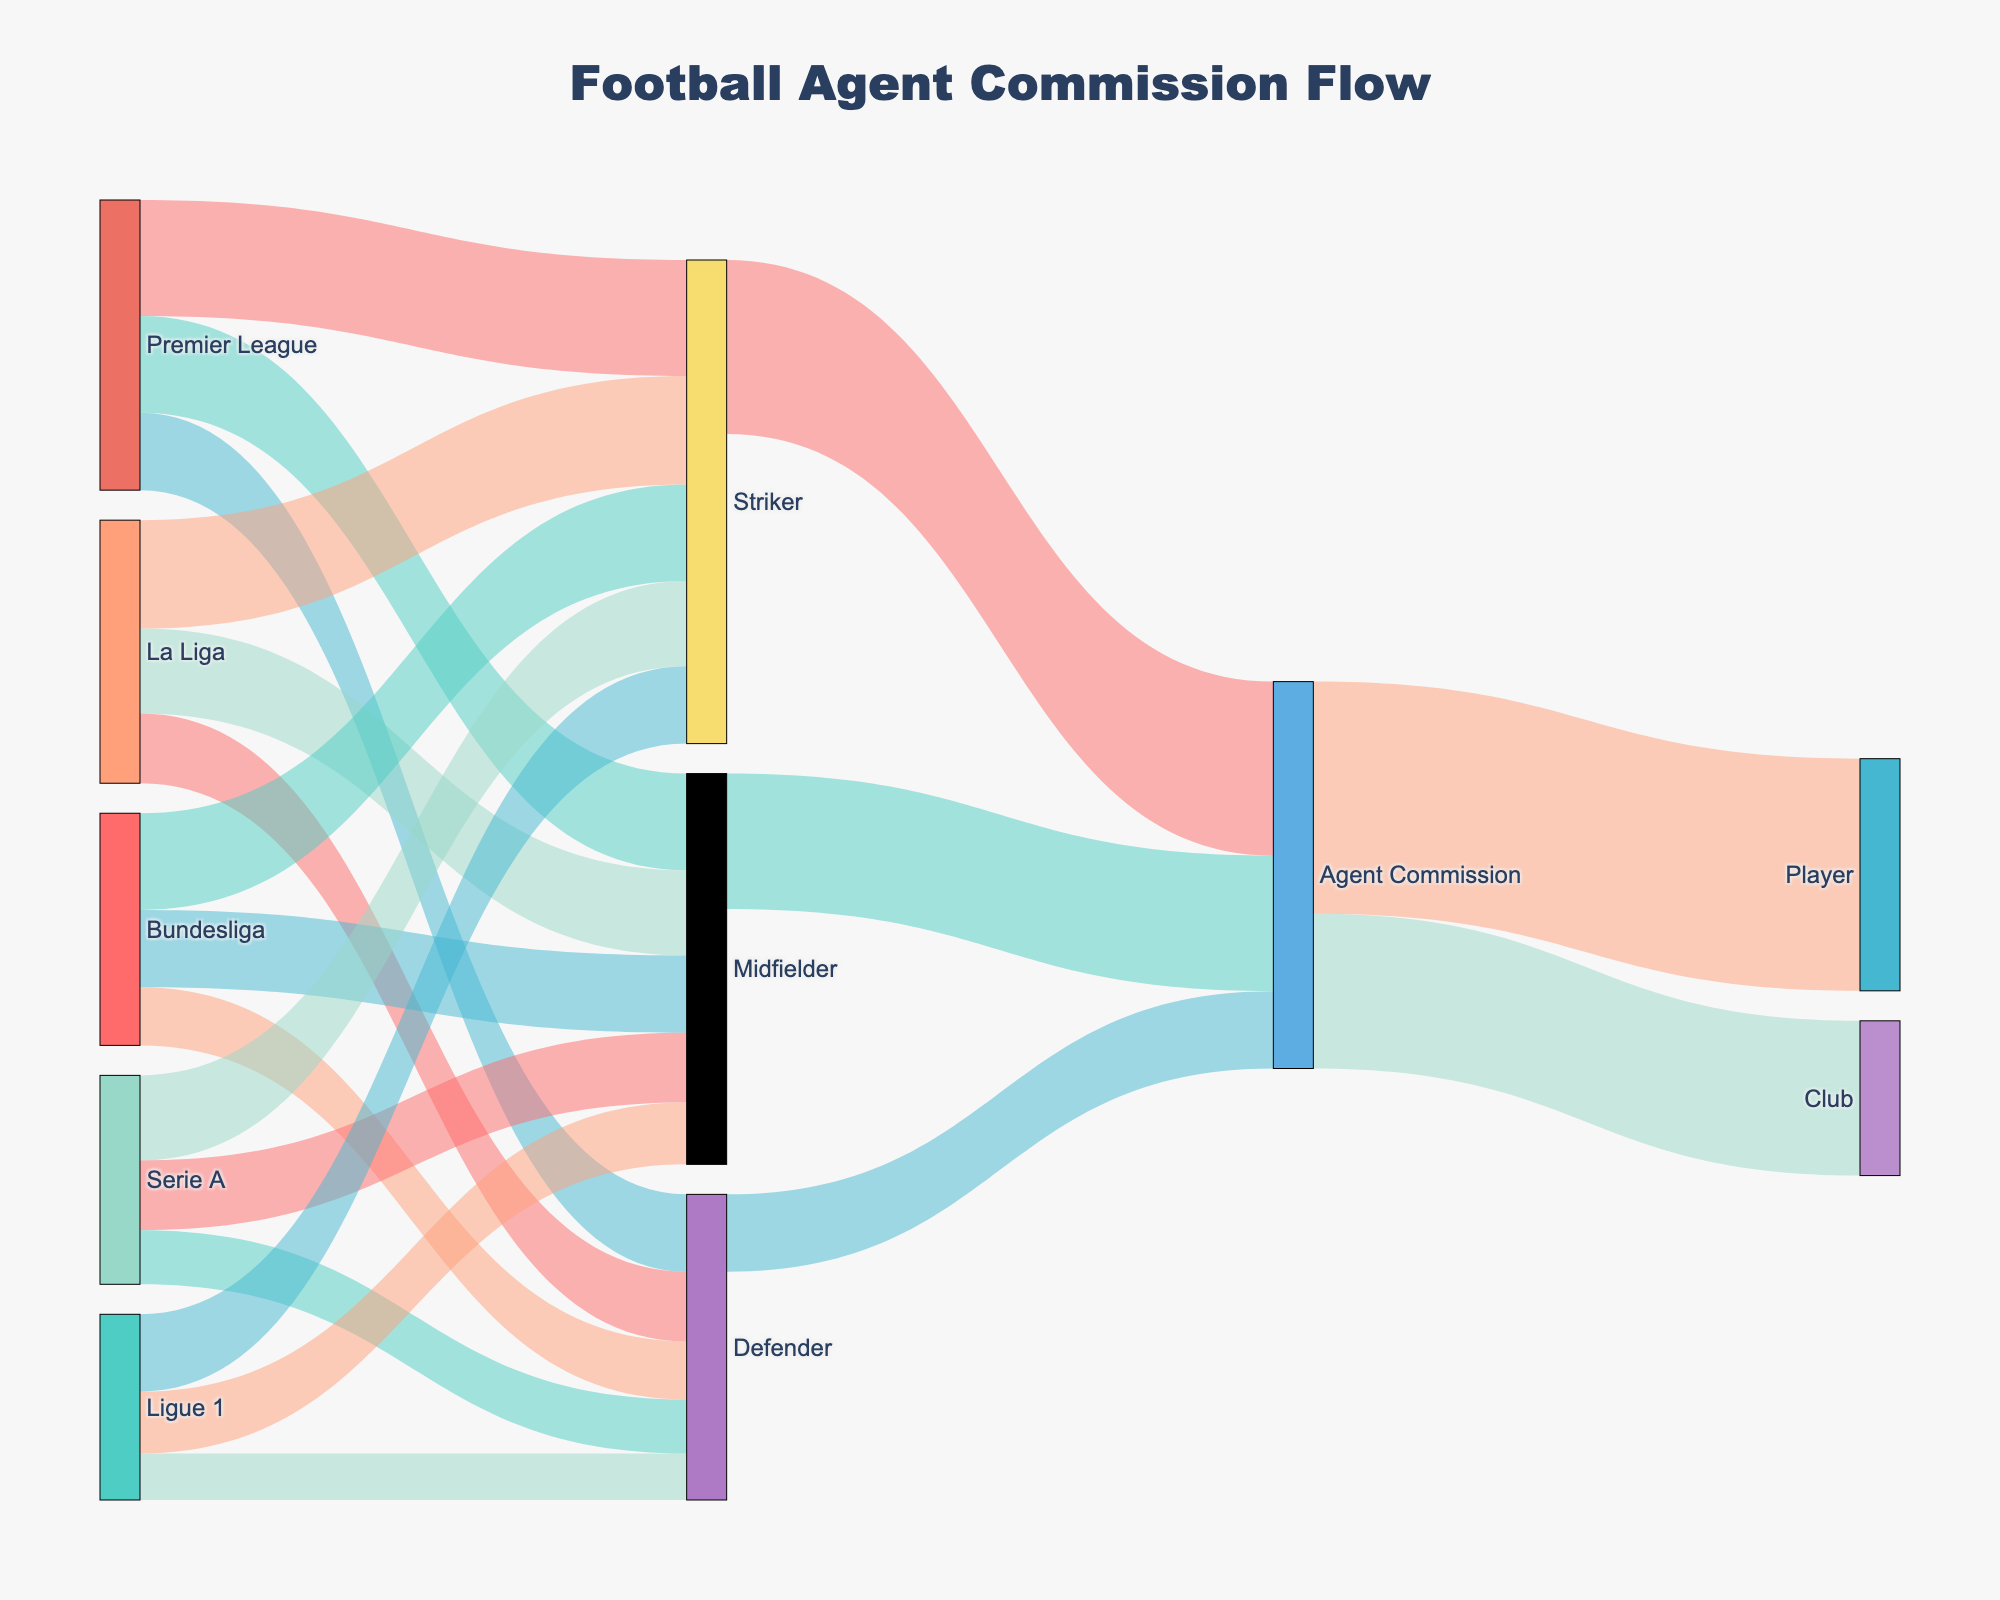What is the title of the Sankey diagram? The title is located at the top of the figure and represents the overall theme of the diagram. Looking at the title helps to understand the focus of the visual representation.
Answer: Football Agent Commission Flow Which league allocates the highest number of commissions to Strikers? To determine this, look at the links connected from each league to the Striker node. Identify the link with the highest value.
Answer: Premier League How many total agent commissions are allocated to Midfielders across all leagues? Sum the values of the links from all leagues that lead to the Midfielder node. This includes links from Premier League, La Liga, Bundesliga, Serie A, and Ligue 1 to Midfielder.
Answer: 101 Which position receives the least amount of agent commission? Compare the total links connected from each position (Striker, Midfielder, Defender) to the Agent Commission node. Identify which has the lowest value.
Answer: Defender What is the total allocation of agent commissions from the Ligue 1 league? Sum the values of all links from the Ligue 1 league node to player positions.
Answer: 48 How do the commissions allocated to clubs compare to those allocated to players? Look at the values of links from the Agent Commission node to the Player and Club nodes. Compare these values to determine which one is higher.
Answer: Player commissions are higher What is the sum of commissions allocated to Defenders in Serie A and Ligue 1? Add the values of the links from Serie A to Defender and from Ligue 1 to Defender.
Answer: 26 If you sum up the commissions allocated to all leagues, what is the total amount? Sum the values of all links originating from each league node to any player position node. This includes summing up all the allocations from Premier League, La Liga, Bundesliga, Serie A, and Ligue 1.
Answer: 295 Which position in Serie A receives more commissions, Striker or Midfielder? Compare the values of the links originating from Serie A to the Striker and Midfielder nodes. Identify which value is higher.
Answer: Striker What is the overall commission allocated to agent from Strikers, Midfielders, and Defenders? Sum the values of the links from Striker, Midfielder, and Defender nodes to the Agent Commission node. This includes all values linking these positions to Agent Commission.
Answer: 100 